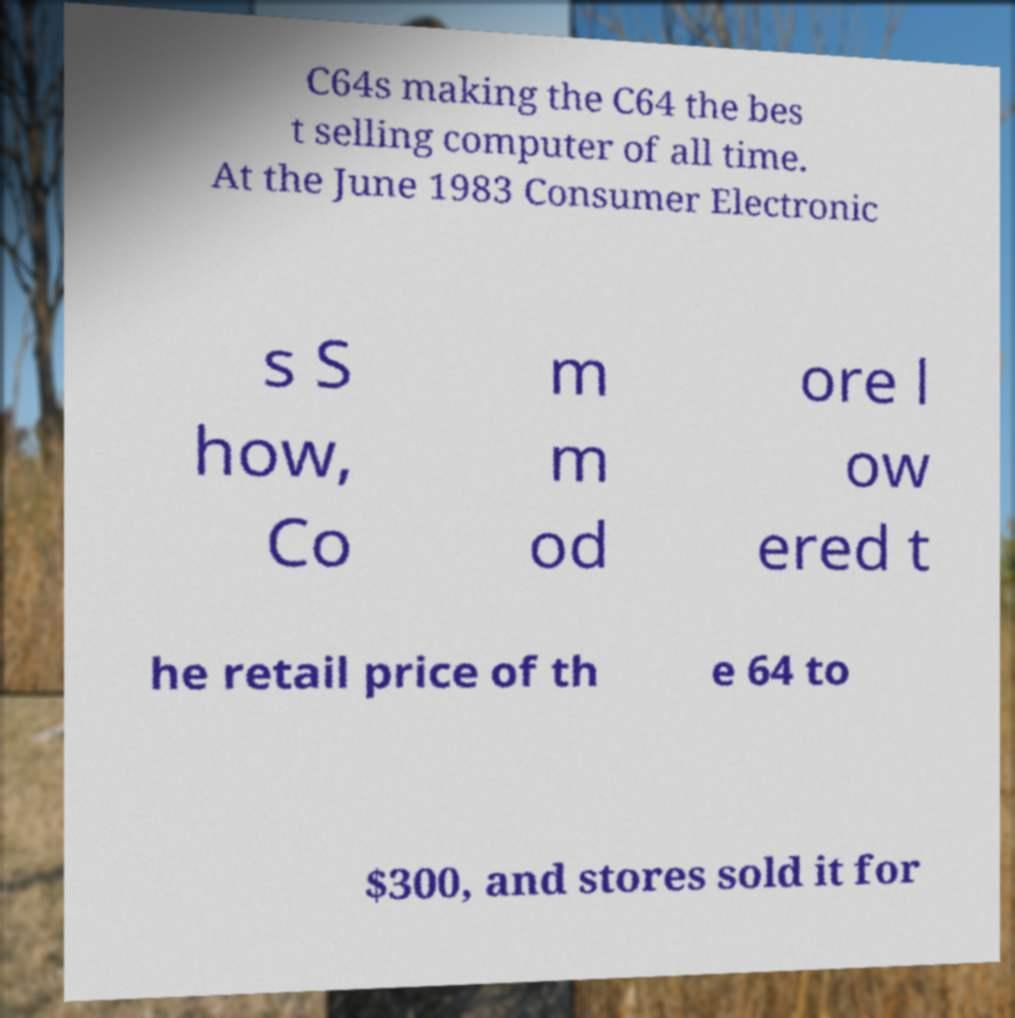Can you read and provide the text displayed in the image?This photo seems to have some interesting text. Can you extract and type it out for me? C64s making the C64 the bes t selling computer of all time. At the June 1983 Consumer Electronic s S how, Co m m od ore l ow ered t he retail price of th e 64 to $300, and stores sold it for 